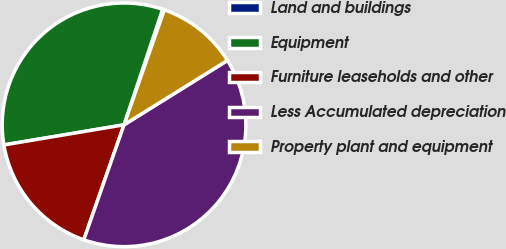Convert chart. <chart><loc_0><loc_0><loc_500><loc_500><pie_chart><fcel>Land and buildings<fcel>Equipment<fcel>Furniture leaseholds and other<fcel>Less Accumulated depreciation<fcel>Property plant and equipment<nl><fcel>0.24%<fcel>32.77%<fcel>17.0%<fcel>39.22%<fcel>10.77%<nl></chart> 